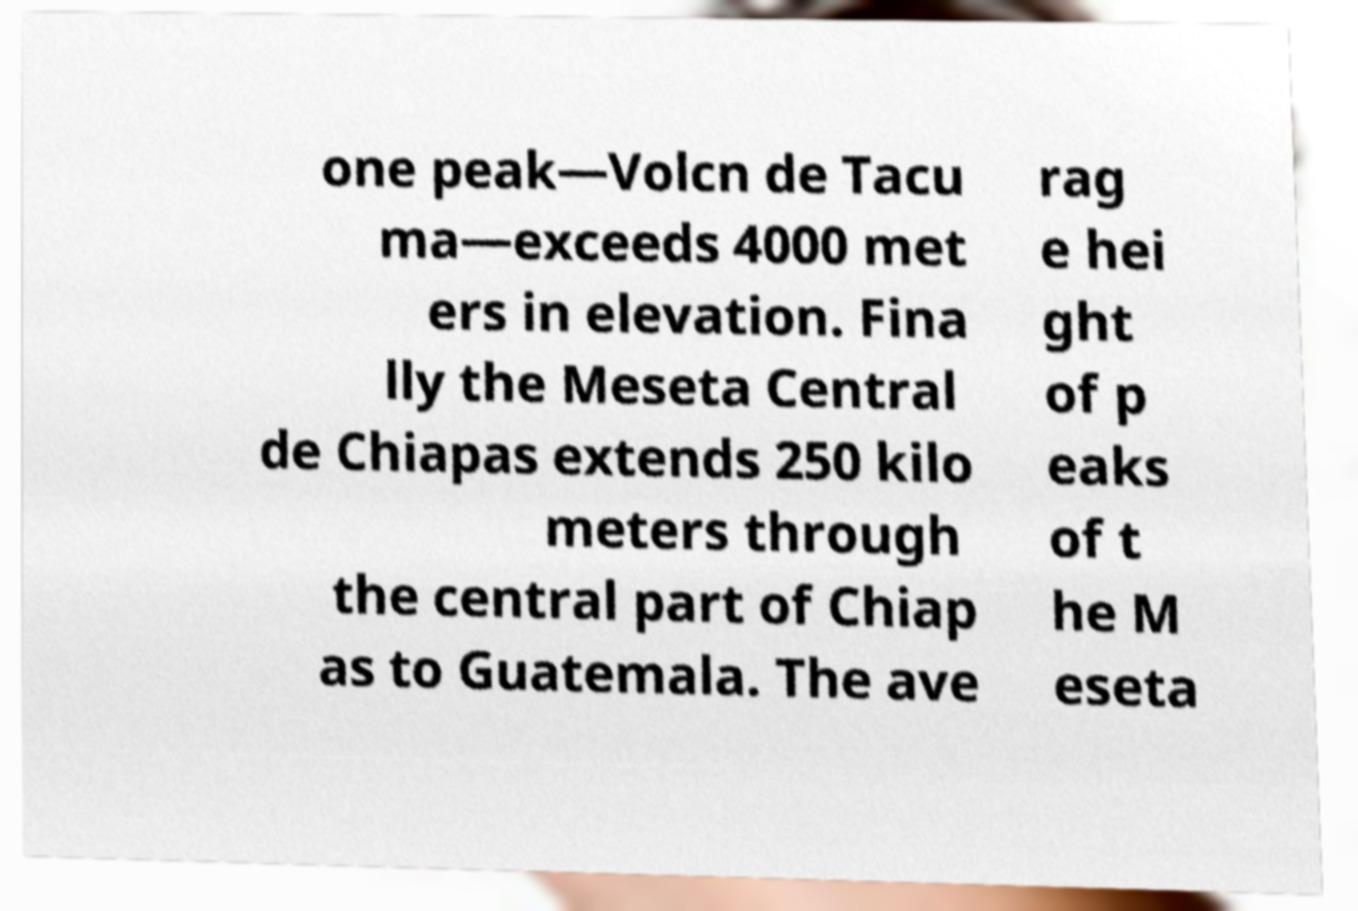Could you extract and type out the text from this image? one peak—Volcn de Tacu ma—exceeds 4000 met ers in elevation. Fina lly the Meseta Central de Chiapas extends 250 kilo meters through the central part of Chiap as to Guatemala. The ave rag e hei ght of p eaks of t he M eseta 